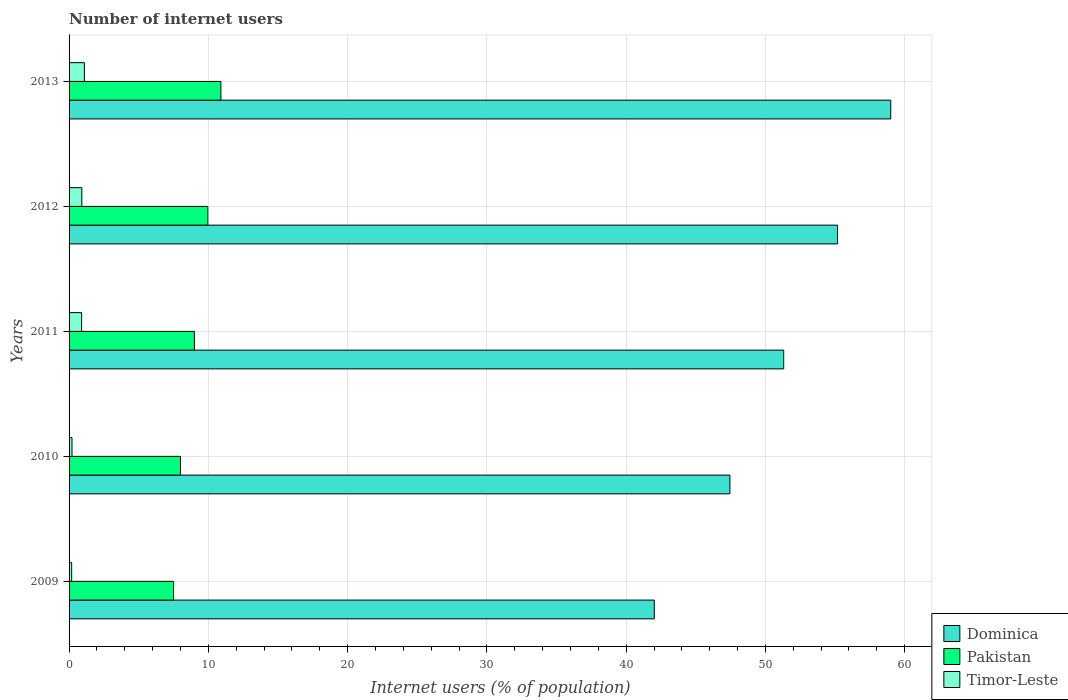How many groups of bars are there?
Your response must be concise. 5. Are the number of bars on each tick of the Y-axis equal?
Provide a succinct answer. Yes. How many bars are there on the 4th tick from the top?
Give a very brief answer. 3. In how many cases, is the number of bars for a given year not equal to the number of legend labels?
Your response must be concise. 0. What is the number of internet users in Timor-Leste in 2009?
Keep it short and to the point. 0.19. Across all years, what is the maximum number of internet users in Pakistan?
Your response must be concise. 10.9. What is the total number of internet users in Timor-Leste in the graph?
Your answer should be very brief. 3.31. What is the difference between the number of internet users in Dominica in 2011 and that in 2013?
Give a very brief answer. -7.69. What is the difference between the number of internet users in Timor-Leste in 2010 and the number of internet users in Pakistan in 2012?
Ensure brevity in your answer.  -9.75. What is the average number of internet users in Pakistan per year?
Offer a terse response. 9.07. In how many years, is the number of internet users in Timor-Leste greater than 56 %?
Your response must be concise. 0. What is the ratio of the number of internet users in Timor-Leste in 2009 to that in 2013?
Your response must be concise. 0.17. Is the number of internet users in Pakistan in 2009 less than that in 2010?
Your answer should be compact. Yes. Is the difference between the number of internet users in Timor-Leste in 2009 and 2013 greater than the difference between the number of internet users in Pakistan in 2009 and 2013?
Provide a short and direct response. Yes. What is the difference between the highest and the second highest number of internet users in Pakistan?
Ensure brevity in your answer.  0.94. What is the difference between the highest and the lowest number of internet users in Pakistan?
Your answer should be compact. 3.4. In how many years, is the number of internet users in Timor-Leste greater than the average number of internet users in Timor-Leste taken over all years?
Provide a short and direct response. 3. Is the sum of the number of internet users in Timor-Leste in 2011 and 2013 greater than the maximum number of internet users in Dominica across all years?
Keep it short and to the point. No. What does the 1st bar from the top in 2009 represents?
Provide a short and direct response. Timor-Leste. What does the 3rd bar from the bottom in 2010 represents?
Your answer should be very brief. Timor-Leste. Are all the bars in the graph horizontal?
Make the answer very short. Yes. How many years are there in the graph?
Offer a terse response. 5. What is the difference between two consecutive major ticks on the X-axis?
Your answer should be very brief. 10. Does the graph contain any zero values?
Offer a very short reply. No. What is the title of the graph?
Give a very brief answer. Number of internet users. What is the label or title of the X-axis?
Your answer should be compact. Internet users (% of population). What is the Internet users (% of population) in Dominica in 2009?
Provide a short and direct response. 42.02. What is the Internet users (% of population) of Pakistan in 2009?
Make the answer very short. 7.5. What is the Internet users (% of population) of Timor-Leste in 2009?
Keep it short and to the point. 0.19. What is the Internet users (% of population) in Dominica in 2010?
Give a very brief answer. 47.45. What is the Internet users (% of population) of Timor-Leste in 2010?
Offer a very short reply. 0.21. What is the Internet users (% of population) of Dominica in 2011?
Your answer should be compact. 51.31. What is the Internet users (% of population) of Pakistan in 2011?
Offer a very short reply. 9. What is the Internet users (% of population) of Dominica in 2012?
Give a very brief answer. 55.18. What is the Internet users (% of population) in Pakistan in 2012?
Make the answer very short. 9.96. What is the Internet users (% of population) of Timor-Leste in 2012?
Provide a succinct answer. 0.91. What is the Internet users (% of population) in Dominica in 2013?
Provide a short and direct response. 59. What is the Internet users (% of population) in Pakistan in 2013?
Your answer should be very brief. 10.9. What is the Internet users (% of population) of Timor-Leste in 2013?
Your response must be concise. 1.1. Across all years, what is the maximum Internet users (% of population) in Dominica?
Keep it short and to the point. 59. Across all years, what is the maximum Internet users (% of population) in Timor-Leste?
Your answer should be compact. 1.1. Across all years, what is the minimum Internet users (% of population) of Dominica?
Ensure brevity in your answer.  42.02. Across all years, what is the minimum Internet users (% of population) of Pakistan?
Keep it short and to the point. 7.5. Across all years, what is the minimum Internet users (% of population) of Timor-Leste?
Offer a terse response. 0.19. What is the total Internet users (% of population) of Dominica in the graph?
Ensure brevity in your answer.  254.96. What is the total Internet users (% of population) in Pakistan in the graph?
Your answer should be compact. 45.36. What is the total Internet users (% of population) of Timor-Leste in the graph?
Your response must be concise. 3.31. What is the difference between the Internet users (% of population) of Dominica in 2009 and that in 2010?
Your answer should be compact. -5.43. What is the difference between the Internet users (% of population) of Timor-Leste in 2009 and that in 2010?
Keep it short and to the point. -0.02. What is the difference between the Internet users (% of population) in Dominica in 2009 and that in 2011?
Ensure brevity in your answer.  -9.29. What is the difference between the Internet users (% of population) of Timor-Leste in 2009 and that in 2011?
Your response must be concise. -0.71. What is the difference between the Internet users (% of population) in Dominica in 2009 and that in 2012?
Offer a terse response. -13.16. What is the difference between the Internet users (% of population) of Pakistan in 2009 and that in 2012?
Ensure brevity in your answer.  -2.46. What is the difference between the Internet users (% of population) in Timor-Leste in 2009 and that in 2012?
Ensure brevity in your answer.  -0.73. What is the difference between the Internet users (% of population) of Dominica in 2009 and that in 2013?
Provide a succinct answer. -16.98. What is the difference between the Internet users (% of population) of Pakistan in 2009 and that in 2013?
Your answer should be compact. -3.4. What is the difference between the Internet users (% of population) of Timor-Leste in 2009 and that in 2013?
Give a very brief answer. -0.91. What is the difference between the Internet users (% of population) of Dominica in 2010 and that in 2011?
Offer a very short reply. -3.86. What is the difference between the Internet users (% of population) in Timor-Leste in 2010 and that in 2011?
Give a very brief answer. -0.69. What is the difference between the Internet users (% of population) in Dominica in 2010 and that in 2012?
Keep it short and to the point. -7.73. What is the difference between the Internet users (% of population) of Pakistan in 2010 and that in 2012?
Make the answer very short. -1.96. What is the difference between the Internet users (% of population) of Timor-Leste in 2010 and that in 2012?
Provide a succinct answer. -0.7. What is the difference between the Internet users (% of population) of Dominica in 2010 and that in 2013?
Your answer should be very brief. -11.55. What is the difference between the Internet users (% of population) in Timor-Leste in 2010 and that in 2013?
Provide a short and direct response. -0.89. What is the difference between the Internet users (% of population) in Dominica in 2011 and that in 2012?
Make the answer very short. -3.86. What is the difference between the Internet users (% of population) in Pakistan in 2011 and that in 2012?
Provide a succinct answer. -0.96. What is the difference between the Internet users (% of population) in Timor-Leste in 2011 and that in 2012?
Give a very brief answer. -0.01. What is the difference between the Internet users (% of population) of Dominica in 2011 and that in 2013?
Your answer should be very brief. -7.69. What is the difference between the Internet users (% of population) in Pakistan in 2011 and that in 2013?
Your answer should be very brief. -1.9. What is the difference between the Internet users (% of population) of Dominica in 2012 and that in 2013?
Give a very brief answer. -3.82. What is the difference between the Internet users (% of population) in Pakistan in 2012 and that in 2013?
Offer a terse response. -0.94. What is the difference between the Internet users (% of population) of Timor-Leste in 2012 and that in 2013?
Keep it short and to the point. -0.19. What is the difference between the Internet users (% of population) in Dominica in 2009 and the Internet users (% of population) in Pakistan in 2010?
Provide a succinct answer. 34.02. What is the difference between the Internet users (% of population) of Dominica in 2009 and the Internet users (% of population) of Timor-Leste in 2010?
Provide a succinct answer. 41.81. What is the difference between the Internet users (% of population) in Pakistan in 2009 and the Internet users (% of population) in Timor-Leste in 2010?
Provide a short and direct response. 7.29. What is the difference between the Internet users (% of population) of Dominica in 2009 and the Internet users (% of population) of Pakistan in 2011?
Offer a very short reply. 33.02. What is the difference between the Internet users (% of population) in Dominica in 2009 and the Internet users (% of population) in Timor-Leste in 2011?
Provide a succinct answer. 41.12. What is the difference between the Internet users (% of population) in Dominica in 2009 and the Internet users (% of population) in Pakistan in 2012?
Provide a succinct answer. 32.06. What is the difference between the Internet users (% of population) in Dominica in 2009 and the Internet users (% of population) in Timor-Leste in 2012?
Provide a succinct answer. 41.11. What is the difference between the Internet users (% of population) in Pakistan in 2009 and the Internet users (% of population) in Timor-Leste in 2012?
Your answer should be compact. 6.59. What is the difference between the Internet users (% of population) of Dominica in 2009 and the Internet users (% of population) of Pakistan in 2013?
Provide a succinct answer. 31.12. What is the difference between the Internet users (% of population) of Dominica in 2009 and the Internet users (% of population) of Timor-Leste in 2013?
Your answer should be compact. 40.92. What is the difference between the Internet users (% of population) of Pakistan in 2009 and the Internet users (% of population) of Timor-Leste in 2013?
Your answer should be very brief. 6.4. What is the difference between the Internet users (% of population) in Dominica in 2010 and the Internet users (% of population) in Pakistan in 2011?
Keep it short and to the point. 38.45. What is the difference between the Internet users (% of population) in Dominica in 2010 and the Internet users (% of population) in Timor-Leste in 2011?
Make the answer very short. 46.55. What is the difference between the Internet users (% of population) in Pakistan in 2010 and the Internet users (% of population) in Timor-Leste in 2011?
Offer a terse response. 7.1. What is the difference between the Internet users (% of population) in Dominica in 2010 and the Internet users (% of population) in Pakistan in 2012?
Offer a very short reply. 37.49. What is the difference between the Internet users (% of population) of Dominica in 2010 and the Internet users (% of population) of Timor-Leste in 2012?
Ensure brevity in your answer.  46.54. What is the difference between the Internet users (% of population) in Pakistan in 2010 and the Internet users (% of population) in Timor-Leste in 2012?
Offer a very short reply. 7.09. What is the difference between the Internet users (% of population) of Dominica in 2010 and the Internet users (% of population) of Pakistan in 2013?
Provide a short and direct response. 36.55. What is the difference between the Internet users (% of population) in Dominica in 2010 and the Internet users (% of population) in Timor-Leste in 2013?
Offer a very short reply. 46.35. What is the difference between the Internet users (% of population) in Dominica in 2011 and the Internet users (% of population) in Pakistan in 2012?
Your answer should be compact. 41.35. What is the difference between the Internet users (% of population) of Dominica in 2011 and the Internet users (% of population) of Timor-Leste in 2012?
Provide a short and direct response. 50.4. What is the difference between the Internet users (% of population) of Pakistan in 2011 and the Internet users (% of population) of Timor-Leste in 2012?
Provide a succinct answer. 8.09. What is the difference between the Internet users (% of population) of Dominica in 2011 and the Internet users (% of population) of Pakistan in 2013?
Provide a succinct answer. 40.41. What is the difference between the Internet users (% of population) in Dominica in 2011 and the Internet users (% of population) in Timor-Leste in 2013?
Your answer should be very brief. 50.21. What is the difference between the Internet users (% of population) of Dominica in 2012 and the Internet users (% of population) of Pakistan in 2013?
Provide a short and direct response. 44.28. What is the difference between the Internet users (% of population) of Dominica in 2012 and the Internet users (% of population) of Timor-Leste in 2013?
Your answer should be very brief. 54.08. What is the difference between the Internet users (% of population) of Pakistan in 2012 and the Internet users (% of population) of Timor-Leste in 2013?
Your answer should be compact. 8.86. What is the average Internet users (% of population) in Dominica per year?
Your response must be concise. 50.99. What is the average Internet users (% of population) of Pakistan per year?
Your answer should be compact. 9.07. What is the average Internet users (% of population) in Timor-Leste per year?
Provide a succinct answer. 0.66. In the year 2009, what is the difference between the Internet users (% of population) in Dominica and Internet users (% of population) in Pakistan?
Keep it short and to the point. 34.52. In the year 2009, what is the difference between the Internet users (% of population) in Dominica and Internet users (% of population) in Timor-Leste?
Your response must be concise. 41.83. In the year 2009, what is the difference between the Internet users (% of population) of Pakistan and Internet users (% of population) of Timor-Leste?
Your response must be concise. 7.31. In the year 2010, what is the difference between the Internet users (% of population) in Dominica and Internet users (% of population) in Pakistan?
Keep it short and to the point. 39.45. In the year 2010, what is the difference between the Internet users (% of population) of Dominica and Internet users (% of population) of Timor-Leste?
Provide a succinct answer. 47.24. In the year 2010, what is the difference between the Internet users (% of population) in Pakistan and Internet users (% of population) in Timor-Leste?
Provide a succinct answer. 7.79. In the year 2011, what is the difference between the Internet users (% of population) of Dominica and Internet users (% of population) of Pakistan?
Offer a terse response. 42.31. In the year 2011, what is the difference between the Internet users (% of population) in Dominica and Internet users (% of population) in Timor-Leste?
Your response must be concise. 50.41. In the year 2011, what is the difference between the Internet users (% of population) of Pakistan and Internet users (% of population) of Timor-Leste?
Your answer should be compact. 8.1. In the year 2012, what is the difference between the Internet users (% of population) of Dominica and Internet users (% of population) of Pakistan?
Make the answer very short. 45.22. In the year 2012, what is the difference between the Internet users (% of population) in Dominica and Internet users (% of population) in Timor-Leste?
Ensure brevity in your answer.  54.26. In the year 2012, what is the difference between the Internet users (% of population) in Pakistan and Internet users (% of population) in Timor-Leste?
Your answer should be very brief. 9.05. In the year 2013, what is the difference between the Internet users (% of population) in Dominica and Internet users (% of population) in Pakistan?
Offer a very short reply. 48.1. In the year 2013, what is the difference between the Internet users (% of population) of Dominica and Internet users (% of population) of Timor-Leste?
Your answer should be very brief. 57.9. In the year 2013, what is the difference between the Internet users (% of population) of Pakistan and Internet users (% of population) of Timor-Leste?
Offer a terse response. 9.8. What is the ratio of the Internet users (% of population) in Dominica in 2009 to that in 2010?
Give a very brief answer. 0.89. What is the ratio of the Internet users (% of population) in Pakistan in 2009 to that in 2010?
Provide a short and direct response. 0.94. What is the ratio of the Internet users (% of population) in Timor-Leste in 2009 to that in 2010?
Ensure brevity in your answer.  0.88. What is the ratio of the Internet users (% of population) in Dominica in 2009 to that in 2011?
Make the answer very short. 0.82. What is the ratio of the Internet users (% of population) of Pakistan in 2009 to that in 2011?
Keep it short and to the point. 0.83. What is the ratio of the Internet users (% of population) of Timor-Leste in 2009 to that in 2011?
Offer a terse response. 0.21. What is the ratio of the Internet users (% of population) of Dominica in 2009 to that in 2012?
Ensure brevity in your answer.  0.76. What is the ratio of the Internet users (% of population) of Pakistan in 2009 to that in 2012?
Ensure brevity in your answer.  0.75. What is the ratio of the Internet users (% of population) of Timor-Leste in 2009 to that in 2012?
Your answer should be very brief. 0.2. What is the ratio of the Internet users (% of population) of Dominica in 2009 to that in 2013?
Provide a succinct answer. 0.71. What is the ratio of the Internet users (% of population) of Pakistan in 2009 to that in 2013?
Provide a short and direct response. 0.69. What is the ratio of the Internet users (% of population) of Timor-Leste in 2009 to that in 2013?
Give a very brief answer. 0.17. What is the ratio of the Internet users (% of population) in Dominica in 2010 to that in 2011?
Your answer should be very brief. 0.92. What is the ratio of the Internet users (% of population) of Timor-Leste in 2010 to that in 2011?
Provide a short and direct response. 0.23. What is the ratio of the Internet users (% of population) of Dominica in 2010 to that in 2012?
Offer a very short reply. 0.86. What is the ratio of the Internet users (% of population) of Pakistan in 2010 to that in 2012?
Offer a very short reply. 0.8. What is the ratio of the Internet users (% of population) of Timor-Leste in 2010 to that in 2012?
Make the answer very short. 0.23. What is the ratio of the Internet users (% of population) in Dominica in 2010 to that in 2013?
Ensure brevity in your answer.  0.8. What is the ratio of the Internet users (% of population) of Pakistan in 2010 to that in 2013?
Offer a terse response. 0.73. What is the ratio of the Internet users (% of population) of Timor-Leste in 2010 to that in 2013?
Your answer should be very brief. 0.19. What is the ratio of the Internet users (% of population) in Dominica in 2011 to that in 2012?
Keep it short and to the point. 0.93. What is the ratio of the Internet users (% of population) in Pakistan in 2011 to that in 2012?
Ensure brevity in your answer.  0.9. What is the ratio of the Internet users (% of population) in Timor-Leste in 2011 to that in 2012?
Give a very brief answer. 0.98. What is the ratio of the Internet users (% of population) in Dominica in 2011 to that in 2013?
Keep it short and to the point. 0.87. What is the ratio of the Internet users (% of population) in Pakistan in 2011 to that in 2013?
Offer a terse response. 0.83. What is the ratio of the Internet users (% of population) of Timor-Leste in 2011 to that in 2013?
Provide a succinct answer. 0.82. What is the ratio of the Internet users (% of population) of Dominica in 2012 to that in 2013?
Your response must be concise. 0.94. What is the ratio of the Internet users (% of population) in Pakistan in 2012 to that in 2013?
Your response must be concise. 0.91. What is the ratio of the Internet users (% of population) in Timor-Leste in 2012 to that in 2013?
Give a very brief answer. 0.83. What is the difference between the highest and the second highest Internet users (% of population) in Dominica?
Provide a short and direct response. 3.82. What is the difference between the highest and the second highest Internet users (% of population) in Pakistan?
Ensure brevity in your answer.  0.94. What is the difference between the highest and the second highest Internet users (% of population) of Timor-Leste?
Provide a short and direct response. 0.19. What is the difference between the highest and the lowest Internet users (% of population) of Dominica?
Offer a terse response. 16.98. What is the difference between the highest and the lowest Internet users (% of population) in Timor-Leste?
Your answer should be compact. 0.91. 